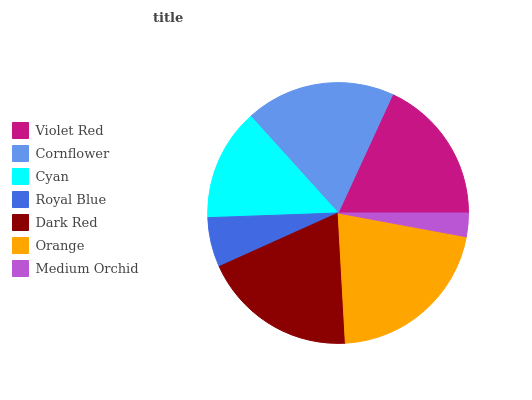Is Medium Orchid the minimum?
Answer yes or no. Yes. Is Orange the maximum?
Answer yes or no. Yes. Is Cornflower the minimum?
Answer yes or no. No. Is Cornflower the maximum?
Answer yes or no. No. Is Cornflower greater than Violet Red?
Answer yes or no. Yes. Is Violet Red less than Cornflower?
Answer yes or no. Yes. Is Violet Red greater than Cornflower?
Answer yes or no. No. Is Cornflower less than Violet Red?
Answer yes or no. No. Is Violet Red the high median?
Answer yes or no. Yes. Is Violet Red the low median?
Answer yes or no. Yes. Is Orange the high median?
Answer yes or no. No. Is Cornflower the low median?
Answer yes or no. No. 